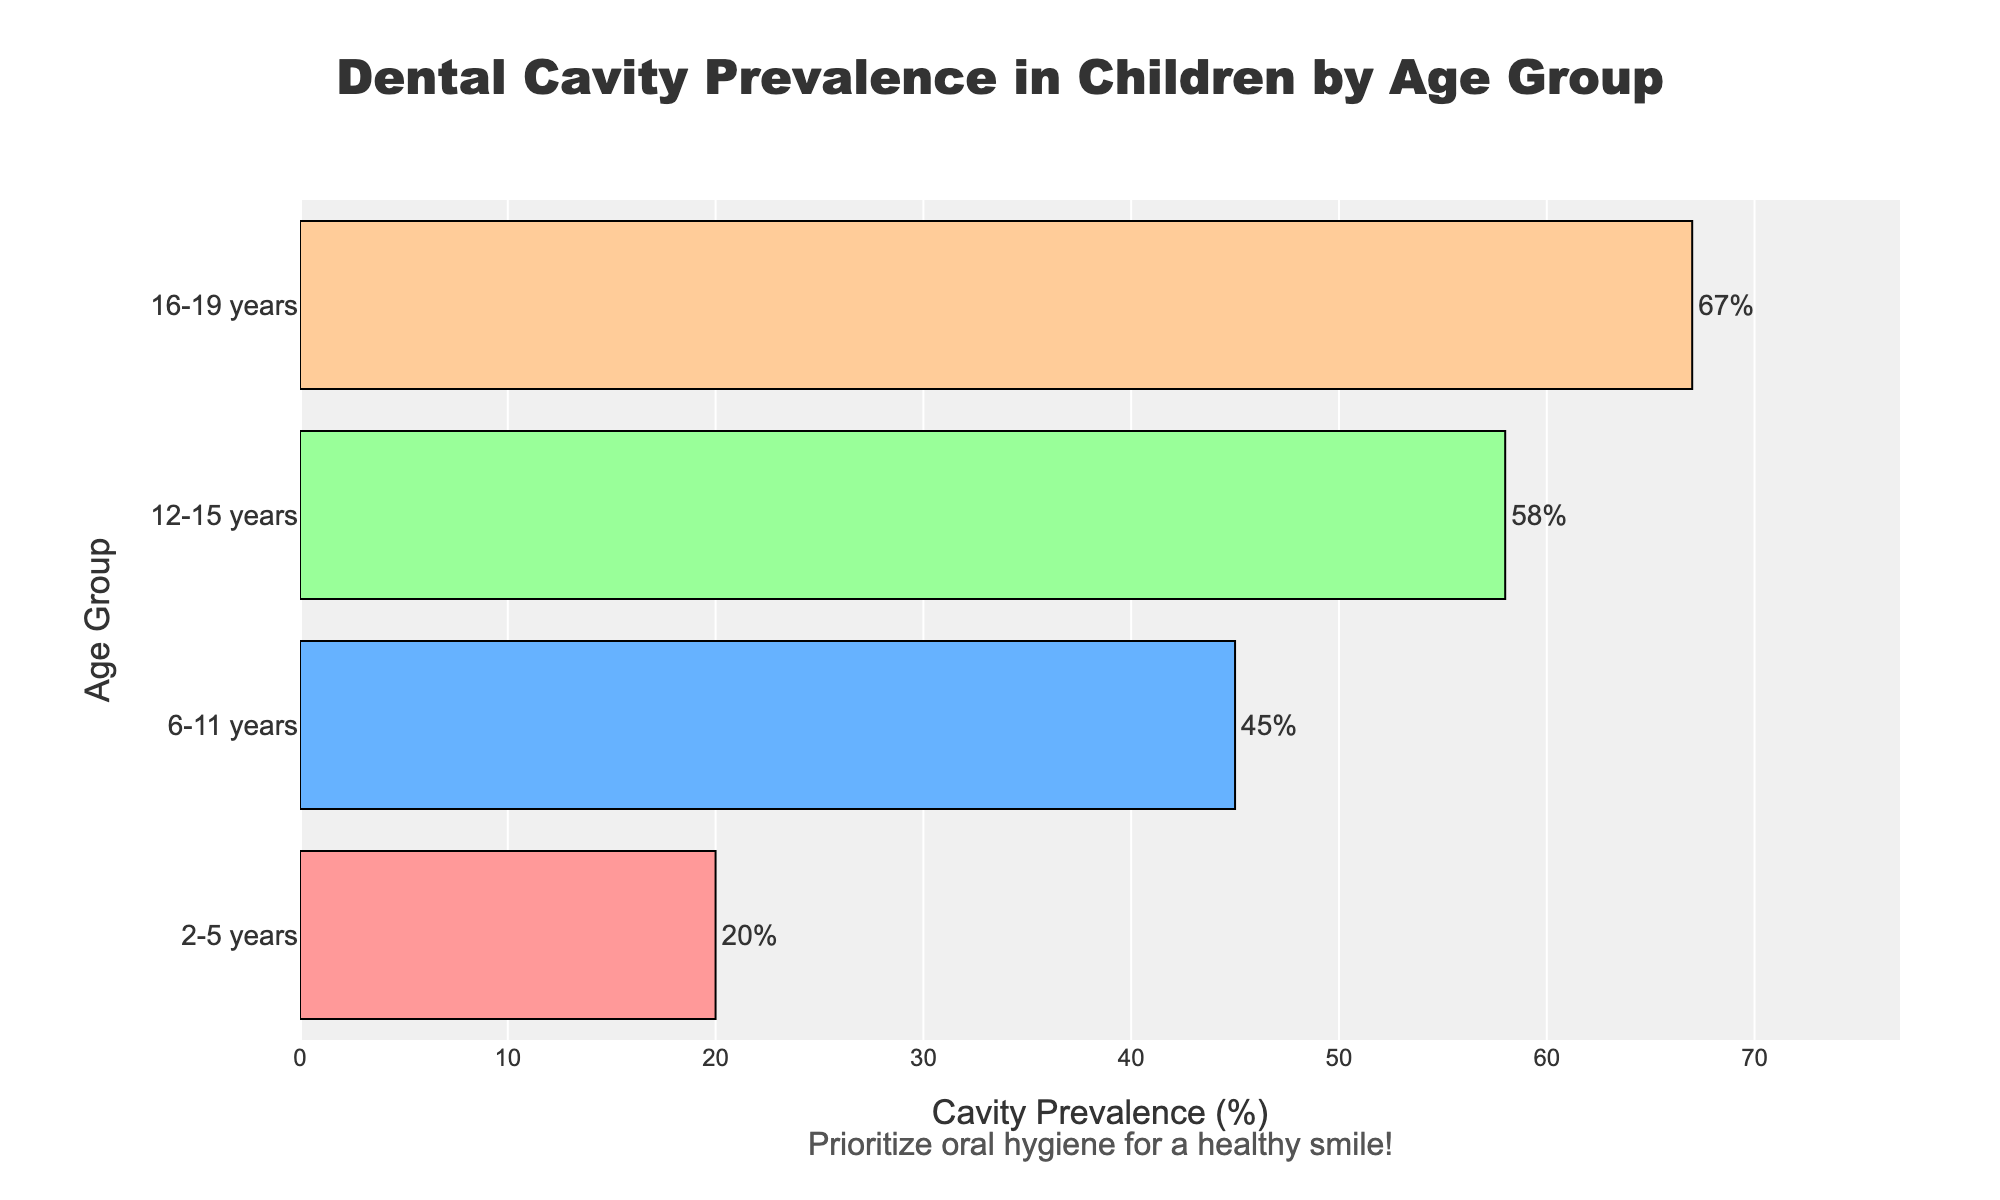What is the title of the figure? The title is usually displayed at the top of the figure. In this case, it is visible as "Dental Cavity Prevalence in Children by Age Group".
Answer: Dental Cavity Prevalence in Children by Age Group What is the age group with the lowest cavity prevalence? To find the age group with the lowest cavity prevalence, look at the bar with the smallest value on the x-axis. The bar for "2-5 years" has the lowest prevalence at 20%.
Answer: 2-5 years How much higher is cavity prevalence in the 12-15 years age group compared to the 6-11 years age group? Subtract the prevalence of 6-11 years (45%) from that of 12-15 years (58%). 58% - 45% = 13%.
Answer: 13% Which age group has the highest cavity prevalence? The bar that extends the farthest to the right on the x-axis represents the age group with the highest prevalence. This is the "16-19 years" group with a prevalence of 67%.
Answer: 16-19 years What is the average cavity prevalence across all age groups? Add all the prevalence values and divide by the number of age groups: (20 + 45 + 58 + 67) / 4 = 47.5%.
Answer: 47.5% Compare the cavity prevalence between the 2-5 years and 16-19 years age groups. By how much does the prevalence increase? Subtract the prevalence of 2-5 years (20%) from that of 16-19 years (67%). 67% - 20% = 47%.
Answer: 47% What is the sum of cavity prevalence percentages for all age groups combined? Add all the percentages together: 20 + 45 + 58 + 67 = 190%.
Answer: 190% What is the difference in cavity prevalence between the 6-11 years and 12-15 years age groups? Subtract the prevalence of 6-11 years (45%) from that of 12-15 years (58%). 58% - 45% = 13%.
Answer: 13% What color is used to represent the 6-11 years age group in the bar chart? The color representation can be visually inspected in the chart; the 6-11 years age group is represented by blue.
Answer: Blue What unique message is added below the plot? The message can be found below the plot in the annotation section. It says, "Prioritize oral hygiene for a healthy smile!"
Answer: Prioritize oral hygiene for a healthy smile! 